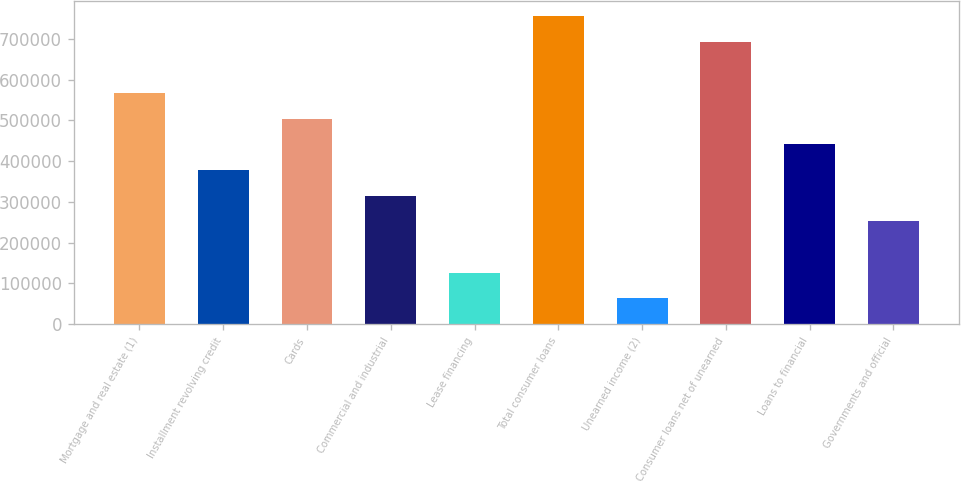Convert chart. <chart><loc_0><loc_0><loc_500><loc_500><bar_chart><fcel>Mortgage and real estate (1)<fcel>Installment revolving credit<fcel>Cards<fcel>Commercial and industrial<fcel>Lease financing<fcel>Total consumer loans<fcel>Unearned income (2)<fcel>Consumer loans net of unearned<fcel>Loans to financial<fcel>Governments and official<nl><fcel>567009<fcel>378007<fcel>504008<fcel>315006<fcel>126005<fcel>756010<fcel>63004.4<fcel>693010<fcel>441007<fcel>252006<nl></chart> 